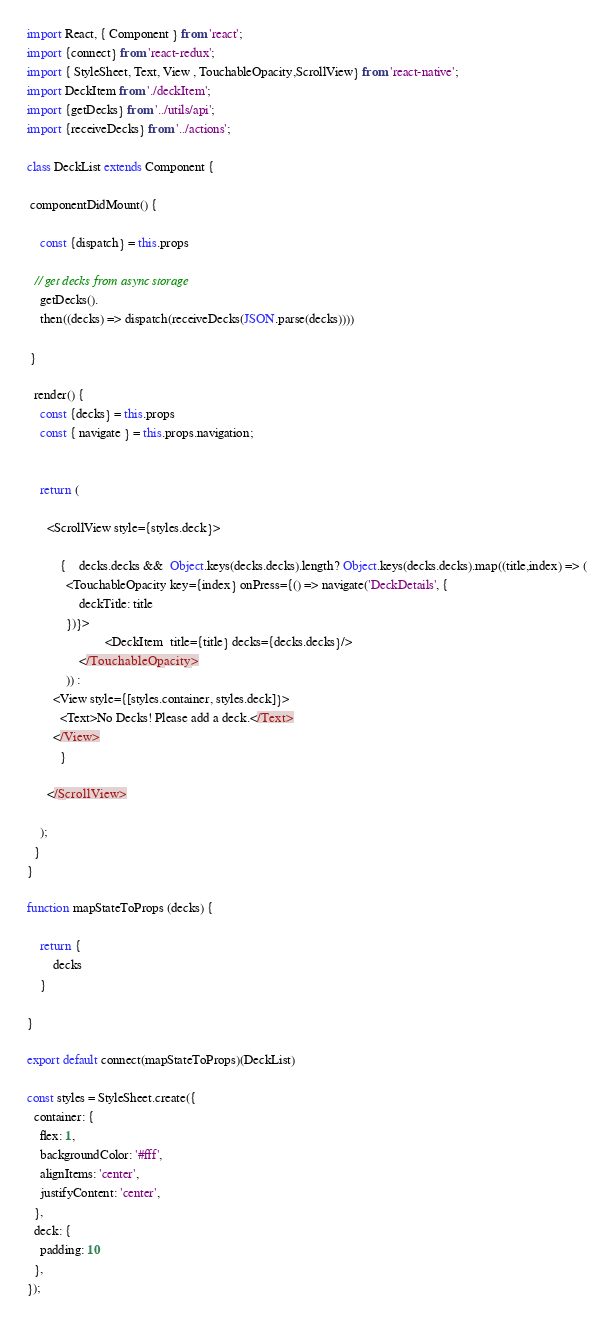Convert code to text. <code><loc_0><loc_0><loc_500><loc_500><_JavaScript_>import React, { Component } from 'react';
import {connect} from 'react-redux';
import { StyleSheet, Text, View , TouchableOpacity,ScrollView} from 'react-native';
import DeckItem from './deckItem';
import {getDecks} from '../utils/api';
import {receiveDecks} from '../actions';

class DeckList extends Component {

 componentDidMount() {

 	const {dispatch} = this.props

  // get decks from async storage
 	getDecks().
 	then((decks) => dispatch(receiveDecks(JSON.parse(decks))))

 }

  render() {
  	const {decks} = this.props
  	const { navigate } = this.props.navigation;


    return (

      <ScrollView style={styles.deck}>

	      {	decks.decks &&  Object.keys(decks.decks).length? Object.keys(decks.decks).map((title,index) => (
	      	<TouchableOpacity key={index} onPress={() => navigate('DeckDetails', {
	      		deckTitle: title
	      	})}>
				        <DeckItem  title={title} decks={decks.decks}/>
			    </TouchableOpacity>
			)) :
        <View style={[styles.container, styles.deck]}>
          <Text>No Decks! Please add a deck.</Text>
        </View>
	      }

      </ScrollView>

    );
  }
}

function mapStateToProps (decks) {

	return {
		decks
	}

}

export default connect(mapStateToProps)(DeckList)

const styles = StyleSheet.create({
  container: {
    flex: 1,
    backgroundColor: '#fff',
    alignItems: 'center',
    justifyContent: 'center',
  },
  deck: {
   	padding: 10
  },
});
</code> 